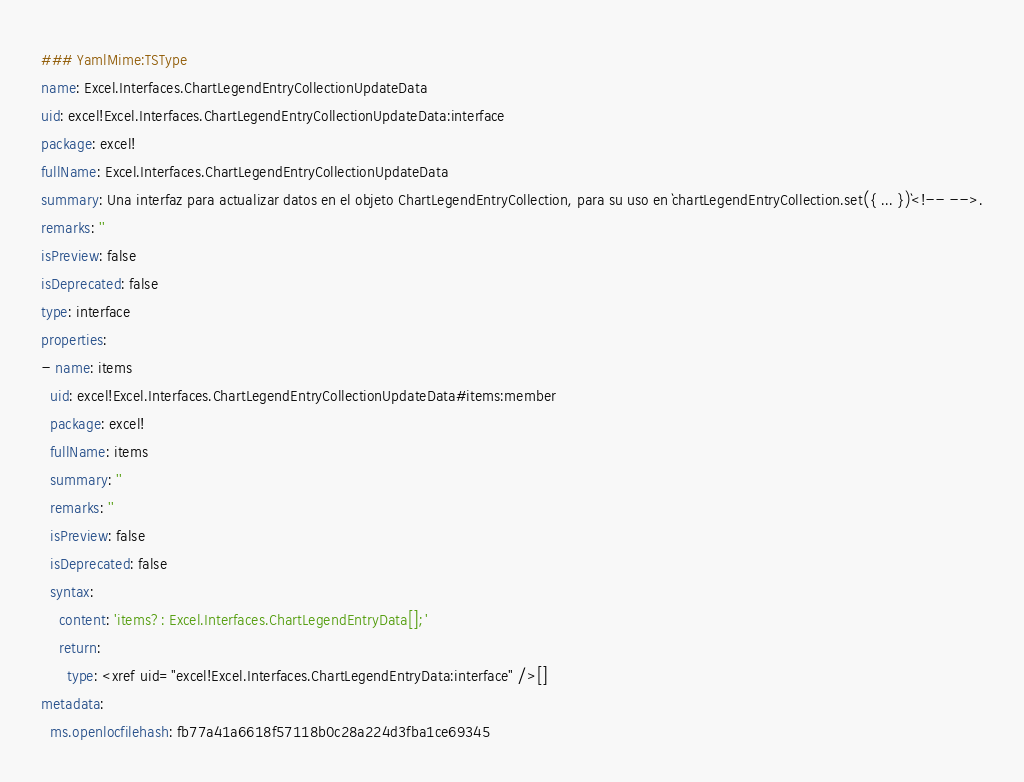<code> <loc_0><loc_0><loc_500><loc_500><_YAML_>### YamlMime:TSType
name: Excel.Interfaces.ChartLegendEntryCollectionUpdateData
uid: excel!Excel.Interfaces.ChartLegendEntryCollectionUpdateData:interface
package: excel!
fullName: Excel.Interfaces.ChartLegendEntryCollectionUpdateData
summary: Una interfaz para actualizar datos en el objeto ChartLegendEntryCollection, para su uso en `chartLegendEntryCollection.set({ ... })`<!-- -->.
remarks: ''
isPreview: false
isDeprecated: false
type: interface
properties:
- name: items
  uid: excel!Excel.Interfaces.ChartLegendEntryCollectionUpdateData#items:member
  package: excel!
  fullName: items
  summary: ''
  remarks: ''
  isPreview: false
  isDeprecated: false
  syntax:
    content: 'items?: Excel.Interfaces.ChartLegendEntryData[];'
    return:
      type: <xref uid="excel!Excel.Interfaces.ChartLegendEntryData:interface" />[]
metadata:
  ms.openlocfilehash: fb77a41a6618f57118b0c28a224d3fba1ce69345</code> 